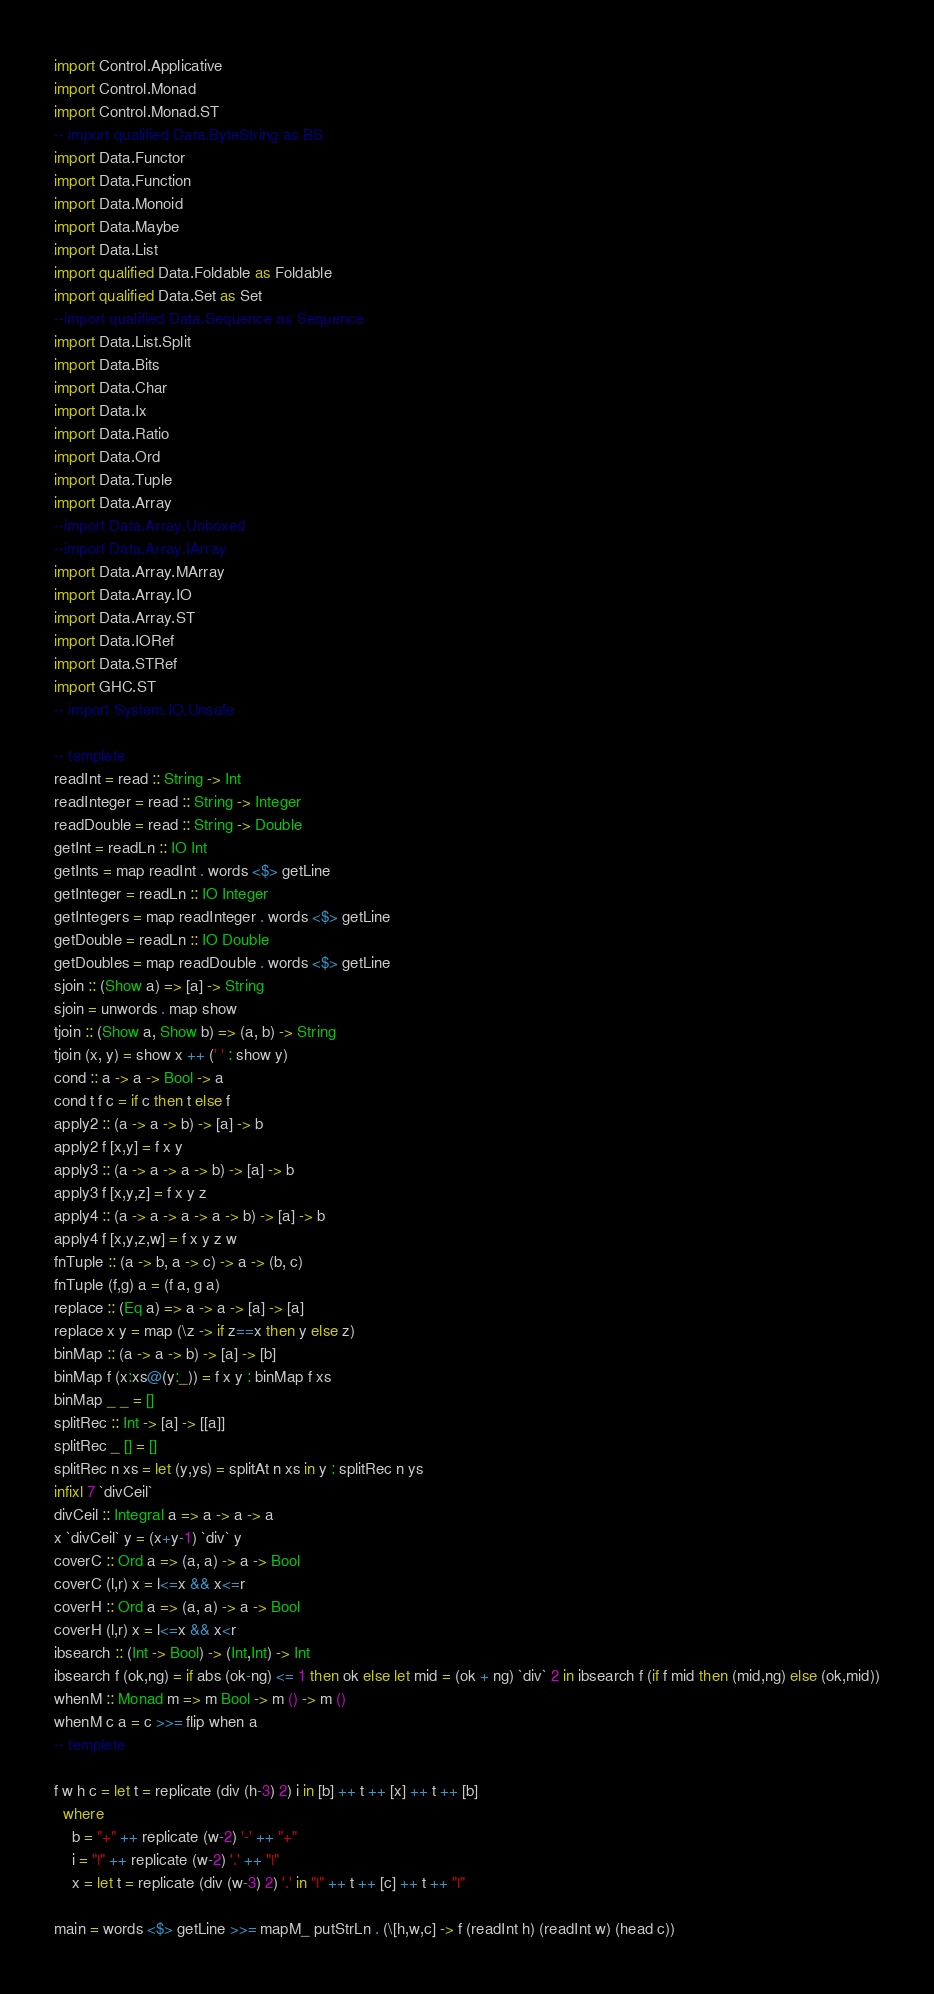<code> <loc_0><loc_0><loc_500><loc_500><_Haskell_>import Control.Applicative
import Control.Monad
import Control.Monad.ST
-- import qualified Data.ByteString as BS
import Data.Functor
import Data.Function
import Data.Monoid
import Data.Maybe
import Data.List
import qualified Data.Foldable as Foldable
import qualified Data.Set as Set
--import qualified Data.Sequence as Sequence
import Data.List.Split
import Data.Bits
import Data.Char
import Data.Ix
import Data.Ratio
import Data.Ord
import Data.Tuple
import Data.Array
--import Data.Array.Unboxed
--import Data.Array.IArray
import Data.Array.MArray
import Data.Array.IO
import Data.Array.ST
import Data.IORef
import Data.STRef
import GHC.ST
-- import System.IO.Unsafe
 
-- templete
readInt = read :: String -> Int
readInteger = read :: String -> Integer
readDouble = read :: String -> Double
getInt = readLn :: IO Int
getInts = map readInt . words <$> getLine
getInteger = readLn :: IO Integer
getIntegers = map readInteger . words <$> getLine
getDouble = readLn :: IO Double
getDoubles = map readDouble . words <$> getLine
sjoin :: (Show a) => [a] -> String
sjoin = unwords . map show
tjoin :: (Show a, Show b) => (a, b) -> String
tjoin (x, y) = show x ++ (' ' : show y)
cond :: a -> a -> Bool -> a
cond t f c = if c then t else f
apply2 :: (a -> a -> b) -> [a] -> b
apply2 f [x,y] = f x y
apply3 :: (a -> a -> a -> b) -> [a] -> b
apply3 f [x,y,z] = f x y z
apply4 :: (a -> a -> a -> a -> b) -> [a] -> b
apply4 f [x,y,z,w] = f x y z w
fnTuple :: (a -> b, a -> c) -> a -> (b, c)
fnTuple (f,g) a = (f a, g a)
replace :: (Eq a) => a -> a -> [a] -> [a]
replace x y = map (\z -> if z==x then y else z)
binMap :: (a -> a -> b) -> [a] -> [b]
binMap f (x:xs@(y:_)) = f x y : binMap f xs
binMap _ _ = []
splitRec :: Int -> [a] -> [[a]]
splitRec _ [] = []
splitRec n xs = let (y,ys) = splitAt n xs in y : splitRec n ys
infixl 7 `divCeil`
divCeil :: Integral a => a -> a -> a
x `divCeil` y = (x+y-1) `div` y
coverC :: Ord a => (a, a) -> a -> Bool
coverC (l,r) x = l<=x && x<=r
coverH :: Ord a => (a, a) -> a -> Bool
coverH (l,r) x = l<=x && x<r
ibsearch :: (Int -> Bool) -> (Int,Int) -> Int
ibsearch f (ok,ng) = if abs (ok-ng) <= 1 then ok else let mid = (ok + ng) `div` 2 in ibsearch f (if f mid then (mid,ng) else (ok,mid))
whenM :: Monad m => m Bool -> m () -> m ()
whenM c a = c >>= flip when a
-- templete

f w h c = let t = replicate (div (h-3) 2) i in [b] ++ t ++ [x] ++ t ++ [b]
  where
    b = "+" ++ replicate (w-2) '-' ++ "+"
    i = "|" ++ replicate (w-2) '.' ++ "|"
    x = let t = replicate (div (w-3) 2) '.' in "|" ++ t ++ [c] ++ t ++ "|"

main = words <$> getLine >>= mapM_ putStrLn . (\[h,w,c] -> f (readInt h) (readInt w) (head c))
</code> 